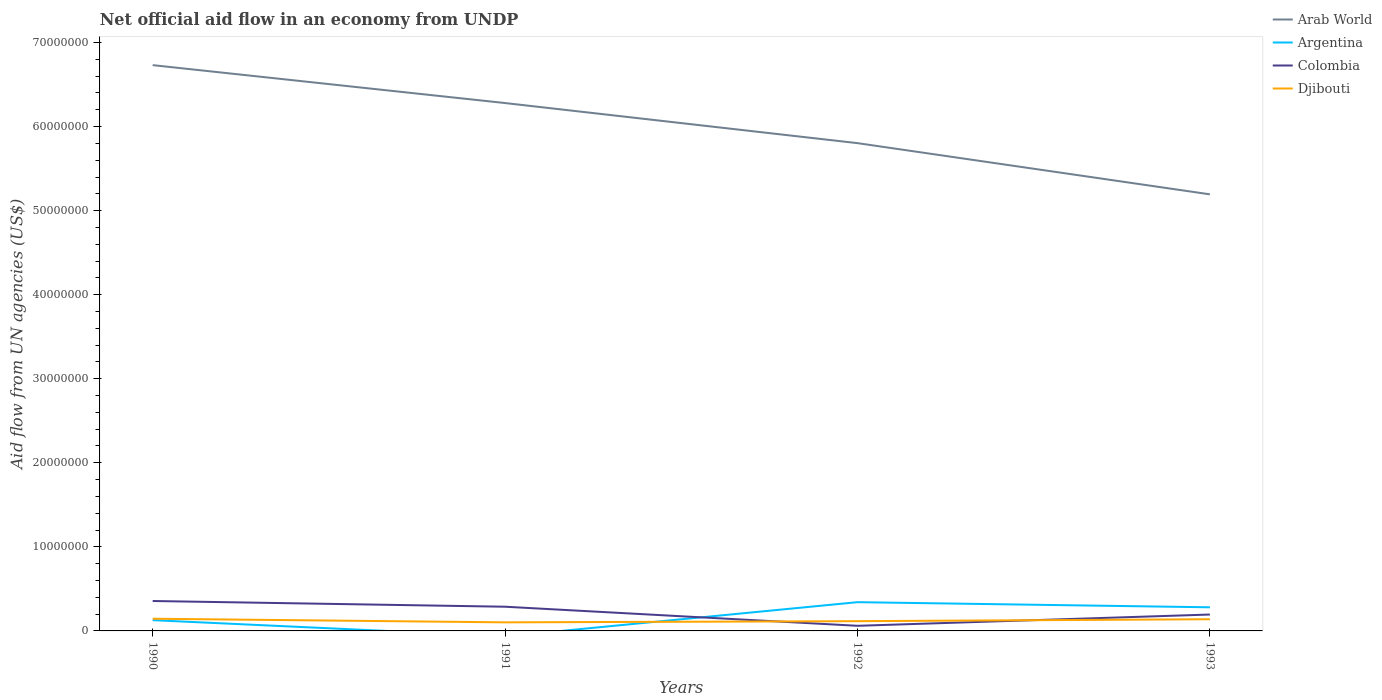Does the line corresponding to Djibouti intersect with the line corresponding to Argentina?
Offer a terse response. Yes. Across all years, what is the maximum net official aid flow in Djibouti?
Make the answer very short. 1.02e+06. What is the total net official aid flow in Colombia in the graph?
Your answer should be compact. 9.30e+05. What is the difference between the highest and the second highest net official aid flow in Argentina?
Give a very brief answer. 3.42e+06. What is the difference between the highest and the lowest net official aid flow in Argentina?
Your response must be concise. 2. Is the net official aid flow in Arab World strictly greater than the net official aid flow in Djibouti over the years?
Your response must be concise. No. What is the difference between two consecutive major ticks on the Y-axis?
Your answer should be compact. 1.00e+07. Are the values on the major ticks of Y-axis written in scientific E-notation?
Offer a terse response. No. Does the graph contain grids?
Provide a short and direct response. No. Where does the legend appear in the graph?
Give a very brief answer. Top right. How many legend labels are there?
Offer a very short reply. 4. What is the title of the graph?
Give a very brief answer. Net official aid flow in an economy from UNDP. Does "Burkina Faso" appear as one of the legend labels in the graph?
Make the answer very short. No. What is the label or title of the X-axis?
Provide a succinct answer. Years. What is the label or title of the Y-axis?
Give a very brief answer. Aid flow from UN agencies (US$). What is the Aid flow from UN agencies (US$) in Arab World in 1990?
Keep it short and to the point. 6.73e+07. What is the Aid flow from UN agencies (US$) in Argentina in 1990?
Keep it short and to the point. 1.28e+06. What is the Aid flow from UN agencies (US$) of Colombia in 1990?
Your answer should be very brief. 3.56e+06. What is the Aid flow from UN agencies (US$) in Djibouti in 1990?
Make the answer very short. 1.45e+06. What is the Aid flow from UN agencies (US$) in Arab World in 1991?
Your answer should be very brief. 6.28e+07. What is the Aid flow from UN agencies (US$) in Argentina in 1991?
Your response must be concise. 0. What is the Aid flow from UN agencies (US$) in Colombia in 1991?
Keep it short and to the point. 2.88e+06. What is the Aid flow from UN agencies (US$) of Djibouti in 1991?
Offer a terse response. 1.02e+06. What is the Aid flow from UN agencies (US$) in Arab World in 1992?
Make the answer very short. 5.80e+07. What is the Aid flow from UN agencies (US$) of Argentina in 1992?
Your answer should be very brief. 3.42e+06. What is the Aid flow from UN agencies (US$) of Colombia in 1992?
Provide a succinct answer. 6.10e+05. What is the Aid flow from UN agencies (US$) in Djibouti in 1992?
Ensure brevity in your answer.  1.16e+06. What is the Aid flow from UN agencies (US$) of Arab World in 1993?
Your answer should be very brief. 5.19e+07. What is the Aid flow from UN agencies (US$) of Argentina in 1993?
Provide a succinct answer. 2.81e+06. What is the Aid flow from UN agencies (US$) of Colombia in 1993?
Keep it short and to the point. 1.95e+06. What is the Aid flow from UN agencies (US$) of Djibouti in 1993?
Make the answer very short. 1.39e+06. Across all years, what is the maximum Aid flow from UN agencies (US$) of Arab World?
Provide a succinct answer. 6.73e+07. Across all years, what is the maximum Aid flow from UN agencies (US$) in Argentina?
Your answer should be compact. 3.42e+06. Across all years, what is the maximum Aid flow from UN agencies (US$) in Colombia?
Ensure brevity in your answer.  3.56e+06. Across all years, what is the maximum Aid flow from UN agencies (US$) in Djibouti?
Your answer should be very brief. 1.45e+06. Across all years, what is the minimum Aid flow from UN agencies (US$) of Arab World?
Ensure brevity in your answer.  5.19e+07. Across all years, what is the minimum Aid flow from UN agencies (US$) of Argentina?
Provide a short and direct response. 0. Across all years, what is the minimum Aid flow from UN agencies (US$) of Djibouti?
Offer a very short reply. 1.02e+06. What is the total Aid flow from UN agencies (US$) of Arab World in the graph?
Keep it short and to the point. 2.40e+08. What is the total Aid flow from UN agencies (US$) in Argentina in the graph?
Keep it short and to the point. 7.51e+06. What is the total Aid flow from UN agencies (US$) of Colombia in the graph?
Your answer should be compact. 9.00e+06. What is the total Aid flow from UN agencies (US$) of Djibouti in the graph?
Provide a succinct answer. 5.02e+06. What is the difference between the Aid flow from UN agencies (US$) of Arab World in 1990 and that in 1991?
Offer a very short reply. 4.51e+06. What is the difference between the Aid flow from UN agencies (US$) in Colombia in 1990 and that in 1991?
Offer a very short reply. 6.80e+05. What is the difference between the Aid flow from UN agencies (US$) in Djibouti in 1990 and that in 1991?
Give a very brief answer. 4.30e+05. What is the difference between the Aid flow from UN agencies (US$) in Arab World in 1990 and that in 1992?
Keep it short and to the point. 9.28e+06. What is the difference between the Aid flow from UN agencies (US$) of Argentina in 1990 and that in 1992?
Make the answer very short. -2.14e+06. What is the difference between the Aid flow from UN agencies (US$) in Colombia in 1990 and that in 1992?
Give a very brief answer. 2.95e+06. What is the difference between the Aid flow from UN agencies (US$) of Djibouti in 1990 and that in 1992?
Keep it short and to the point. 2.90e+05. What is the difference between the Aid flow from UN agencies (US$) of Arab World in 1990 and that in 1993?
Keep it short and to the point. 1.54e+07. What is the difference between the Aid flow from UN agencies (US$) of Argentina in 1990 and that in 1993?
Provide a succinct answer. -1.53e+06. What is the difference between the Aid flow from UN agencies (US$) of Colombia in 1990 and that in 1993?
Your response must be concise. 1.61e+06. What is the difference between the Aid flow from UN agencies (US$) in Djibouti in 1990 and that in 1993?
Provide a succinct answer. 6.00e+04. What is the difference between the Aid flow from UN agencies (US$) in Arab World in 1991 and that in 1992?
Your answer should be very brief. 4.77e+06. What is the difference between the Aid flow from UN agencies (US$) of Colombia in 1991 and that in 1992?
Provide a short and direct response. 2.27e+06. What is the difference between the Aid flow from UN agencies (US$) of Arab World in 1991 and that in 1993?
Give a very brief answer. 1.09e+07. What is the difference between the Aid flow from UN agencies (US$) of Colombia in 1991 and that in 1993?
Your response must be concise. 9.30e+05. What is the difference between the Aid flow from UN agencies (US$) of Djibouti in 1991 and that in 1993?
Provide a short and direct response. -3.70e+05. What is the difference between the Aid flow from UN agencies (US$) in Arab World in 1992 and that in 1993?
Offer a terse response. 6.09e+06. What is the difference between the Aid flow from UN agencies (US$) of Colombia in 1992 and that in 1993?
Provide a short and direct response. -1.34e+06. What is the difference between the Aid flow from UN agencies (US$) of Djibouti in 1992 and that in 1993?
Your answer should be very brief. -2.30e+05. What is the difference between the Aid flow from UN agencies (US$) of Arab World in 1990 and the Aid flow from UN agencies (US$) of Colombia in 1991?
Offer a terse response. 6.44e+07. What is the difference between the Aid flow from UN agencies (US$) in Arab World in 1990 and the Aid flow from UN agencies (US$) in Djibouti in 1991?
Provide a succinct answer. 6.63e+07. What is the difference between the Aid flow from UN agencies (US$) of Argentina in 1990 and the Aid flow from UN agencies (US$) of Colombia in 1991?
Offer a terse response. -1.60e+06. What is the difference between the Aid flow from UN agencies (US$) of Argentina in 1990 and the Aid flow from UN agencies (US$) of Djibouti in 1991?
Make the answer very short. 2.60e+05. What is the difference between the Aid flow from UN agencies (US$) of Colombia in 1990 and the Aid flow from UN agencies (US$) of Djibouti in 1991?
Give a very brief answer. 2.54e+06. What is the difference between the Aid flow from UN agencies (US$) of Arab World in 1990 and the Aid flow from UN agencies (US$) of Argentina in 1992?
Your response must be concise. 6.39e+07. What is the difference between the Aid flow from UN agencies (US$) of Arab World in 1990 and the Aid flow from UN agencies (US$) of Colombia in 1992?
Give a very brief answer. 6.67e+07. What is the difference between the Aid flow from UN agencies (US$) of Arab World in 1990 and the Aid flow from UN agencies (US$) of Djibouti in 1992?
Give a very brief answer. 6.62e+07. What is the difference between the Aid flow from UN agencies (US$) in Argentina in 1990 and the Aid flow from UN agencies (US$) in Colombia in 1992?
Give a very brief answer. 6.70e+05. What is the difference between the Aid flow from UN agencies (US$) of Argentina in 1990 and the Aid flow from UN agencies (US$) of Djibouti in 1992?
Give a very brief answer. 1.20e+05. What is the difference between the Aid flow from UN agencies (US$) of Colombia in 1990 and the Aid flow from UN agencies (US$) of Djibouti in 1992?
Make the answer very short. 2.40e+06. What is the difference between the Aid flow from UN agencies (US$) in Arab World in 1990 and the Aid flow from UN agencies (US$) in Argentina in 1993?
Your response must be concise. 6.45e+07. What is the difference between the Aid flow from UN agencies (US$) of Arab World in 1990 and the Aid flow from UN agencies (US$) of Colombia in 1993?
Your response must be concise. 6.54e+07. What is the difference between the Aid flow from UN agencies (US$) in Arab World in 1990 and the Aid flow from UN agencies (US$) in Djibouti in 1993?
Your answer should be very brief. 6.59e+07. What is the difference between the Aid flow from UN agencies (US$) in Argentina in 1990 and the Aid flow from UN agencies (US$) in Colombia in 1993?
Give a very brief answer. -6.70e+05. What is the difference between the Aid flow from UN agencies (US$) of Colombia in 1990 and the Aid flow from UN agencies (US$) of Djibouti in 1993?
Make the answer very short. 2.17e+06. What is the difference between the Aid flow from UN agencies (US$) in Arab World in 1991 and the Aid flow from UN agencies (US$) in Argentina in 1992?
Provide a succinct answer. 5.94e+07. What is the difference between the Aid flow from UN agencies (US$) of Arab World in 1991 and the Aid flow from UN agencies (US$) of Colombia in 1992?
Make the answer very short. 6.22e+07. What is the difference between the Aid flow from UN agencies (US$) in Arab World in 1991 and the Aid flow from UN agencies (US$) in Djibouti in 1992?
Make the answer very short. 6.16e+07. What is the difference between the Aid flow from UN agencies (US$) in Colombia in 1991 and the Aid flow from UN agencies (US$) in Djibouti in 1992?
Keep it short and to the point. 1.72e+06. What is the difference between the Aid flow from UN agencies (US$) in Arab World in 1991 and the Aid flow from UN agencies (US$) in Argentina in 1993?
Offer a very short reply. 6.00e+07. What is the difference between the Aid flow from UN agencies (US$) of Arab World in 1991 and the Aid flow from UN agencies (US$) of Colombia in 1993?
Ensure brevity in your answer.  6.08e+07. What is the difference between the Aid flow from UN agencies (US$) in Arab World in 1991 and the Aid flow from UN agencies (US$) in Djibouti in 1993?
Provide a succinct answer. 6.14e+07. What is the difference between the Aid flow from UN agencies (US$) of Colombia in 1991 and the Aid flow from UN agencies (US$) of Djibouti in 1993?
Your answer should be compact. 1.49e+06. What is the difference between the Aid flow from UN agencies (US$) in Arab World in 1992 and the Aid flow from UN agencies (US$) in Argentina in 1993?
Offer a very short reply. 5.52e+07. What is the difference between the Aid flow from UN agencies (US$) of Arab World in 1992 and the Aid flow from UN agencies (US$) of Colombia in 1993?
Offer a terse response. 5.61e+07. What is the difference between the Aid flow from UN agencies (US$) in Arab World in 1992 and the Aid flow from UN agencies (US$) in Djibouti in 1993?
Provide a short and direct response. 5.66e+07. What is the difference between the Aid flow from UN agencies (US$) of Argentina in 1992 and the Aid flow from UN agencies (US$) of Colombia in 1993?
Provide a short and direct response. 1.47e+06. What is the difference between the Aid flow from UN agencies (US$) of Argentina in 1992 and the Aid flow from UN agencies (US$) of Djibouti in 1993?
Your answer should be very brief. 2.03e+06. What is the difference between the Aid flow from UN agencies (US$) of Colombia in 1992 and the Aid flow from UN agencies (US$) of Djibouti in 1993?
Your response must be concise. -7.80e+05. What is the average Aid flow from UN agencies (US$) in Arab World per year?
Your response must be concise. 6.00e+07. What is the average Aid flow from UN agencies (US$) of Argentina per year?
Provide a short and direct response. 1.88e+06. What is the average Aid flow from UN agencies (US$) in Colombia per year?
Offer a very short reply. 2.25e+06. What is the average Aid flow from UN agencies (US$) of Djibouti per year?
Offer a terse response. 1.26e+06. In the year 1990, what is the difference between the Aid flow from UN agencies (US$) in Arab World and Aid flow from UN agencies (US$) in Argentina?
Provide a succinct answer. 6.60e+07. In the year 1990, what is the difference between the Aid flow from UN agencies (US$) in Arab World and Aid flow from UN agencies (US$) in Colombia?
Give a very brief answer. 6.38e+07. In the year 1990, what is the difference between the Aid flow from UN agencies (US$) of Arab World and Aid flow from UN agencies (US$) of Djibouti?
Offer a terse response. 6.59e+07. In the year 1990, what is the difference between the Aid flow from UN agencies (US$) in Argentina and Aid flow from UN agencies (US$) in Colombia?
Make the answer very short. -2.28e+06. In the year 1990, what is the difference between the Aid flow from UN agencies (US$) in Argentina and Aid flow from UN agencies (US$) in Djibouti?
Your response must be concise. -1.70e+05. In the year 1990, what is the difference between the Aid flow from UN agencies (US$) of Colombia and Aid flow from UN agencies (US$) of Djibouti?
Provide a succinct answer. 2.11e+06. In the year 1991, what is the difference between the Aid flow from UN agencies (US$) of Arab World and Aid flow from UN agencies (US$) of Colombia?
Your response must be concise. 5.99e+07. In the year 1991, what is the difference between the Aid flow from UN agencies (US$) in Arab World and Aid flow from UN agencies (US$) in Djibouti?
Provide a short and direct response. 6.18e+07. In the year 1991, what is the difference between the Aid flow from UN agencies (US$) in Colombia and Aid flow from UN agencies (US$) in Djibouti?
Make the answer very short. 1.86e+06. In the year 1992, what is the difference between the Aid flow from UN agencies (US$) of Arab World and Aid flow from UN agencies (US$) of Argentina?
Provide a succinct answer. 5.46e+07. In the year 1992, what is the difference between the Aid flow from UN agencies (US$) in Arab World and Aid flow from UN agencies (US$) in Colombia?
Your response must be concise. 5.74e+07. In the year 1992, what is the difference between the Aid flow from UN agencies (US$) of Arab World and Aid flow from UN agencies (US$) of Djibouti?
Offer a terse response. 5.69e+07. In the year 1992, what is the difference between the Aid flow from UN agencies (US$) of Argentina and Aid flow from UN agencies (US$) of Colombia?
Ensure brevity in your answer.  2.81e+06. In the year 1992, what is the difference between the Aid flow from UN agencies (US$) in Argentina and Aid flow from UN agencies (US$) in Djibouti?
Ensure brevity in your answer.  2.26e+06. In the year 1992, what is the difference between the Aid flow from UN agencies (US$) in Colombia and Aid flow from UN agencies (US$) in Djibouti?
Provide a succinct answer. -5.50e+05. In the year 1993, what is the difference between the Aid flow from UN agencies (US$) of Arab World and Aid flow from UN agencies (US$) of Argentina?
Offer a terse response. 4.91e+07. In the year 1993, what is the difference between the Aid flow from UN agencies (US$) of Arab World and Aid flow from UN agencies (US$) of Colombia?
Offer a terse response. 5.00e+07. In the year 1993, what is the difference between the Aid flow from UN agencies (US$) of Arab World and Aid flow from UN agencies (US$) of Djibouti?
Your answer should be very brief. 5.06e+07. In the year 1993, what is the difference between the Aid flow from UN agencies (US$) in Argentina and Aid flow from UN agencies (US$) in Colombia?
Ensure brevity in your answer.  8.60e+05. In the year 1993, what is the difference between the Aid flow from UN agencies (US$) of Argentina and Aid flow from UN agencies (US$) of Djibouti?
Give a very brief answer. 1.42e+06. In the year 1993, what is the difference between the Aid flow from UN agencies (US$) in Colombia and Aid flow from UN agencies (US$) in Djibouti?
Your answer should be very brief. 5.60e+05. What is the ratio of the Aid flow from UN agencies (US$) in Arab World in 1990 to that in 1991?
Your answer should be very brief. 1.07. What is the ratio of the Aid flow from UN agencies (US$) in Colombia in 1990 to that in 1991?
Your response must be concise. 1.24. What is the ratio of the Aid flow from UN agencies (US$) of Djibouti in 1990 to that in 1991?
Provide a short and direct response. 1.42. What is the ratio of the Aid flow from UN agencies (US$) of Arab World in 1990 to that in 1992?
Your answer should be compact. 1.16. What is the ratio of the Aid flow from UN agencies (US$) in Argentina in 1990 to that in 1992?
Your answer should be compact. 0.37. What is the ratio of the Aid flow from UN agencies (US$) of Colombia in 1990 to that in 1992?
Give a very brief answer. 5.84. What is the ratio of the Aid flow from UN agencies (US$) in Arab World in 1990 to that in 1993?
Offer a terse response. 1.3. What is the ratio of the Aid flow from UN agencies (US$) of Argentina in 1990 to that in 1993?
Give a very brief answer. 0.46. What is the ratio of the Aid flow from UN agencies (US$) in Colombia in 1990 to that in 1993?
Provide a succinct answer. 1.83. What is the ratio of the Aid flow from UN agencies (US$) in Djibouti in 1990 to that in 1993?
Your answer should be compact. 1.04. What is the ratio of the Aid flow from UN agencies (US$) of Arab World in 1991 to that in 1992?
Your answer should be very brief. 1.08. What is the ratio of the Aid flow from UN agencies (US$) of Colombia in 1991 to that in 1992?
Your answer should be very brief. 4.72. What is the ratio of the Aid flow from UN agencies (US$) in Djibouti in 1991 to that in 1992?
Make the answer very short. 0.88. What is the ratio of the Aid flow from UN agencies (US$) of Arab World in 1991 to that in 1993?
Offer a very short reply. 1.21. What is the ratio of the Aid flow from UN agencies (US$) in Colombia in 1991 to that in 1993?
Offer a terse response. 1.48. What is the ratio of the Aid flow from UN agencies (US$) of Djibouti in 1991 to that in 1993?
Provide a succinct answer. 0.73. What is the ratio of the Aid flow from UN agencies (US$) of Arab World in 1992 to that in 1993?
Provide a short and direct response. 1.12. What is the ratio of the Aid flow from UN agencies (US$) of Argentina in 1992 to that in 1993?
Your answer should be very brief. 1.22. What is the ratio of the Aid flow from UN agencies (US$) in Colombia in 1992 to that in 1993?
Your response must be concise. 0.31. What is the ratio of the Aid flow from UN agencies (US$) of Djibouti in 1992 to that in 1993?
Offer a very short reply. 0.83. What is the difference between the highest and the second highest Aid flow from UN agencies (US$) of Arab World?
Offer a very short reply. 4.51e+06. What is the difference between the highest and the second highest Aid flow from UN agencies (US$) of Colombia?
Ensure brevity in your answer.  6.80e+05. What is the difference between the highest and the lowest Aid flow from UN agencies (US$) of Arab World?
Offer a very short reply. 1.54e+07. What is the difference between the highest and the lowest Aid flow from UN agencies (US$) in Argentina?
Your response must be concise. 3.42e+06. What is the difference between the highest and the lowest Aid flow from UN agencies (US$) of Colombia?
Your response must be concise. 2.95e+06. 